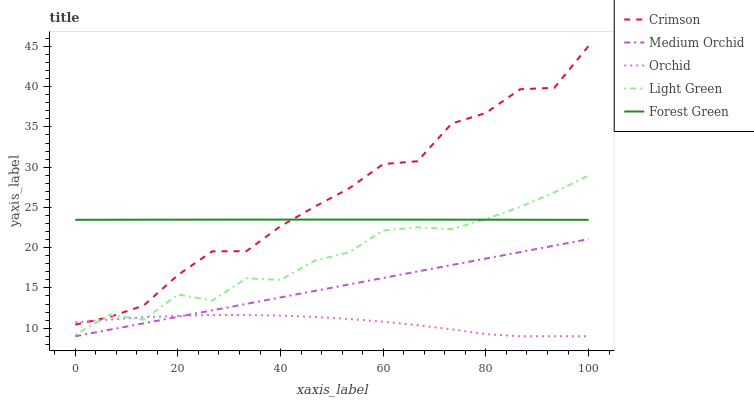Does Orchid have the minimum area under the curve?
Answer yes or no. Yes. Does Crimson have the maximum area under the curve?
Answer yes or no. Yes. Does Forest Green have the minimum area under the curve?
Answer yes or no. No. Does Forest Green have the maximum area under the curve?
Answer yes or no. No. Is Medium Orchid the smoothest?
Answer yes or no. Yes. Is Crimson the roughest?
Answer yes or no. Yes. Is Forest Green the smoothest?
Answer yes or no. No. Is Forest Green the roughest?
Answer yes or no. No. Does Medium Orchid have the lowest value?
Answer yes or no. Yes. Does Forest Green have the lowest value?
Answer yes or no. No. Does Crimson have the highest value?
Answer yes or no. Yes. Does Forest Green have the highest value?
Answer yes or no. No. Is Medium Orchid less than Forest Green?
Answer yes or no. Yes. Is Light Green greater than Medium Orchid?
Answer yes or no. Yes. Does Medium Orchid intersect Orchid?
Answer yes or no. Yes. Is Medium Orchid less than Orchid?
Answer yes or no. No. Is Medium Orchid greater than Orchid?
Answer yes or no. No. Does Medium Orchid intersect Forest Green?
Answer yes or no. No. 